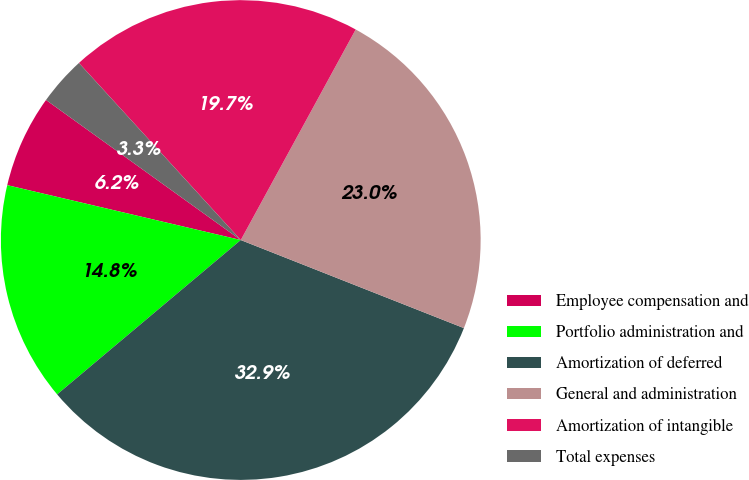Convert chart to OTSL. <chart><loc_0><loc_0><loc_500><loc_500><pie_chart><fcel>Employee compensation and<fcel>Portfolio administration and<fcel>Amortization of deferred<fcel>General and administration<fcel>Amortization of intangible<fcel>Total expenses<nl><fcel>6.25%<fcel>14.8%<fcel>32.89%<fcel>23.03%<fcel>19.74%<fcel>3.29%<nl></chart> 